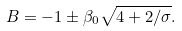<formula> <loc_0><loc_0><loc_500><loc_500>B = - 1 \pm \beta _ { 0 } \sqrt { 4 + 2 / \sigma } .</formula> 